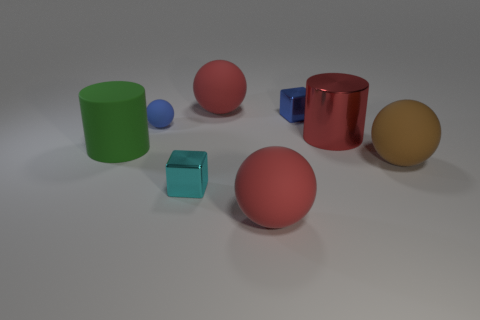What size is the metallic object that is the same color as the small ball?
Your answer should be compact. Small. There is a metal object that is the same color as the tiny ball; what is its shape?
Ensure brevity in your answer.  Cube. Is there any other thing that is the same material as the big green thing?
Provide a short and direct response. Yes. Does the red rubber object that is in front of the large brown object have the same shape as the blue object behind the tiny ball?
Provide a short and direct response. No. What number of cyan metallic blocks are there?
Provide a short and direct response. 1. What shape is the brown object that is the same material as the green thing?
Ensure brevity in your answer.  Sphere. Is there anything else that is the same color as the large rubber cylinder?
Make the answer very short. No. Is the color of the small matte ball the same as the rubber object that is to the left of the small ball?
Give a very brief answer. No. Are there fewer red balls right of the blue cube than brown balls?
Your response must be concise. Yes. There is a red thing in front of the green thing; what is it made of?
Your response must be concise. Rubber. 